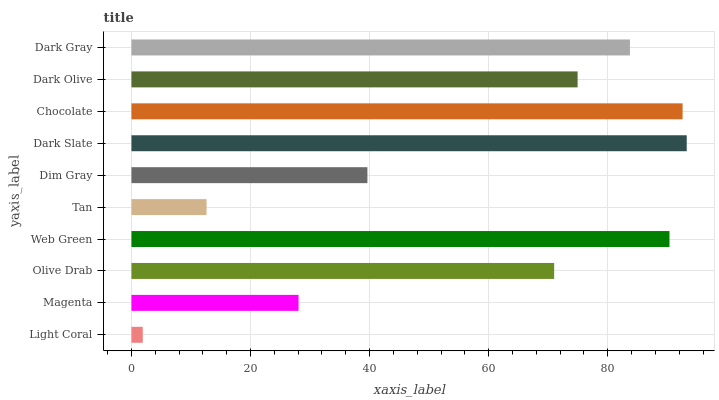Is Light Coral the minimum?
Answer yes or no. Yes. Is Dark Slate the maximum?
Answer yes or no. Yes. Is Magenta the minimum?
Answer yes or no. No. Is Magenta the maximum?
Answer yes or no. No. Is Magenta greater than Light Coral?
Answer yes or no. Yes. Is Light Coral less than Magenta?
Answer yes or no. Yes. Is Light Coral greater than Magenta?
Answer yes or no. No. Is Magenta less than Light Coral?
Answer yes or no. No. Is Dark Olive the high median?
Answer yes or no. Yes. Is Olive Drab the low median?
Answer yes or no. Yes. Is Magenta the high median?
Answer yes or no. No. Is Dim Gray the low median?
Answer yes or no. No. 